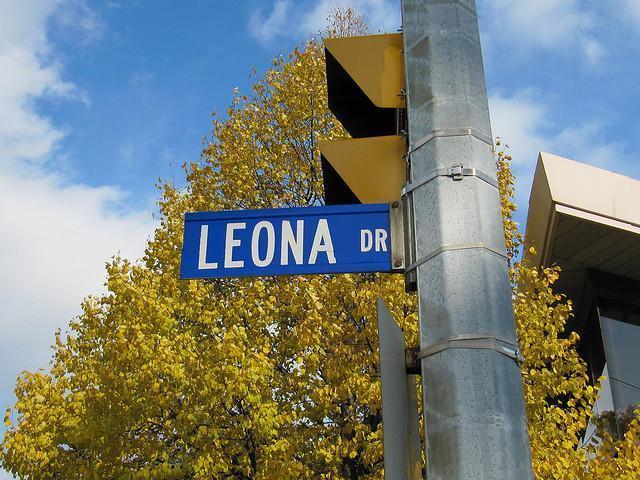How many sign are there?
Give a very brief answer. 1. How many people are there?
Give a very brief answer. 0. 